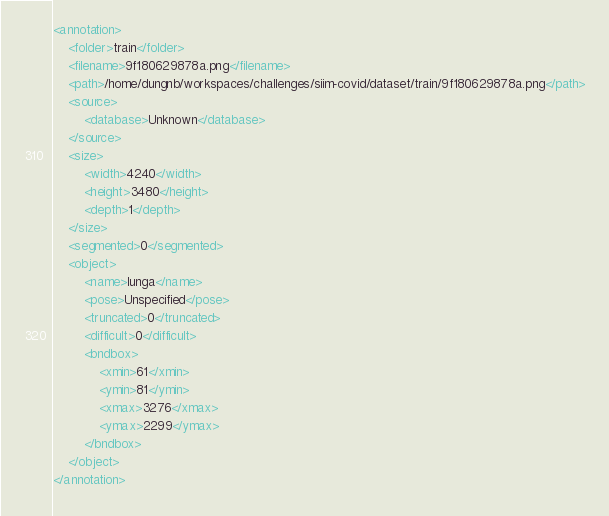Convert code to text. <code><loc_0><loc_0><loc_500><loc_500><_XML_><annotation>
	<folder>train</folder>
	<filename>9f180629878a.png</filename>
	<path>/home/dungnb/workspaces/challenges/siim-covid/dataset/train/9f180629878a.png</path>
	<source>
		<database>Unknown</database>
	</source>
	<size>
		<width>4240</width>
		<height>3480</height>
		<depth>1</depth>
	</size>
	<segmented>0</segmented>
	<object>
		<name>lunga</name>
		<pose>Unspecified</pose>
		<truncated>0</truncated>
		<difficult>0</difficult>
		<bndbox>
			<xmin>61</xmin>
			<ymin>81</ymin>
			<xmax>3276</xmax>
			<ymax>2299</ymax>
		</bndbox>
	</object>
</annotation>
</code> 